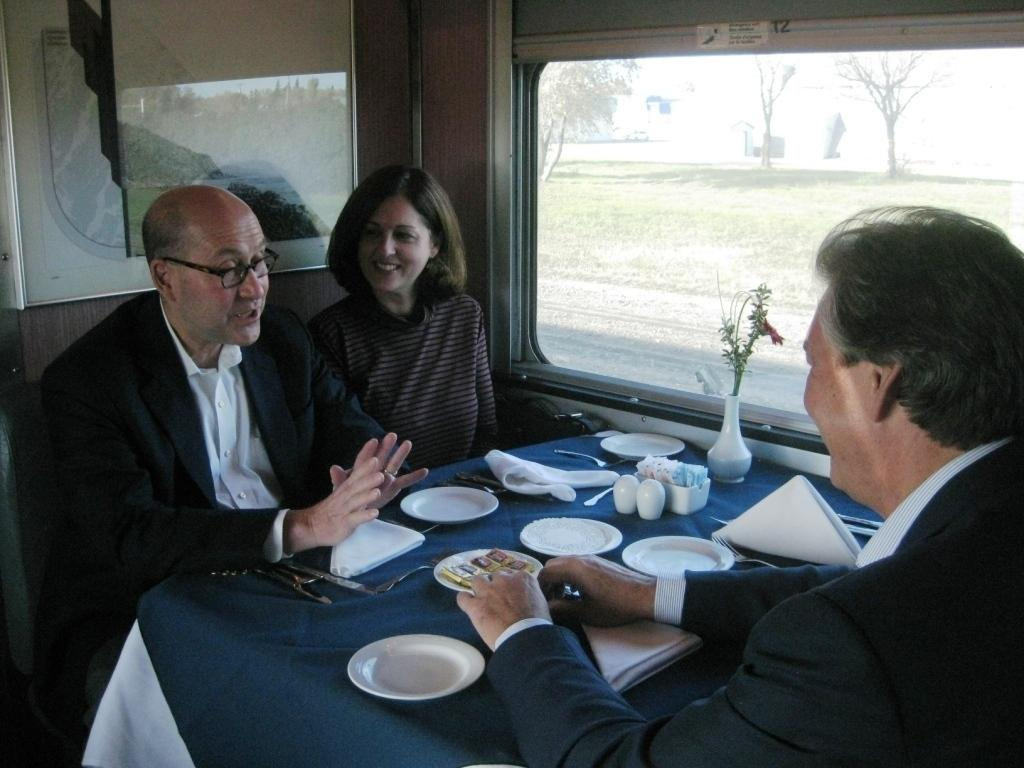How many persons are in the image? There are persons in the image. What are the persons wearing? The persons are wearing clothes. Where are the persons sitting in relation to the table? The persons are sitting in front of a table. What is the location of the table in the room? The table is beside a window. What items can be seen on the table? There are plates, tissues, and a flower vase on the table. What type of snake can be seen slithering across the table in the image? There is no snake present in the image; the table only contains plates, tissues, and a flower vase. What flag is being waved by the persons in the image? There is no flag visible in the image; the persons are simply sitting in front of the table. 